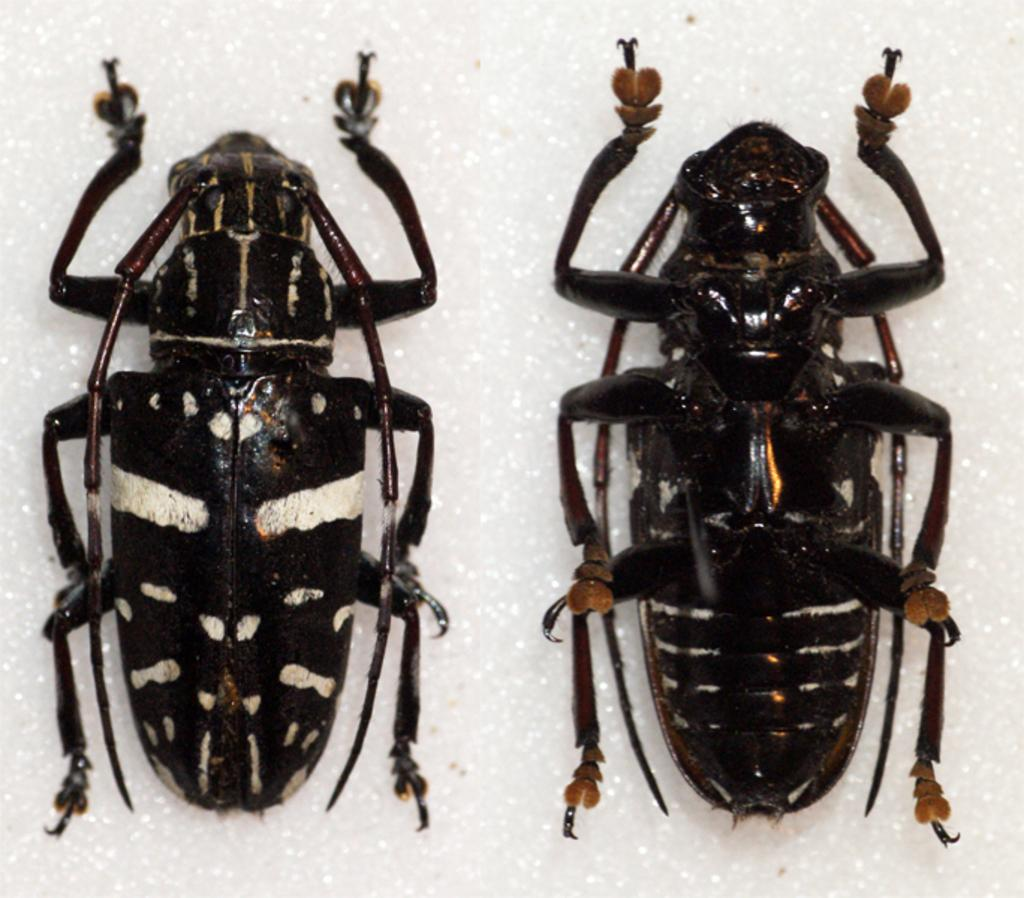What creatures can be seen in the image? There are two ants in the picture. What is the color of the ants? The ants are black in color. What is the background of the image? The background of the image is white. What type of plant can be seen growing in the image? There is no plant present in the image; it features two black ants on a white background. 